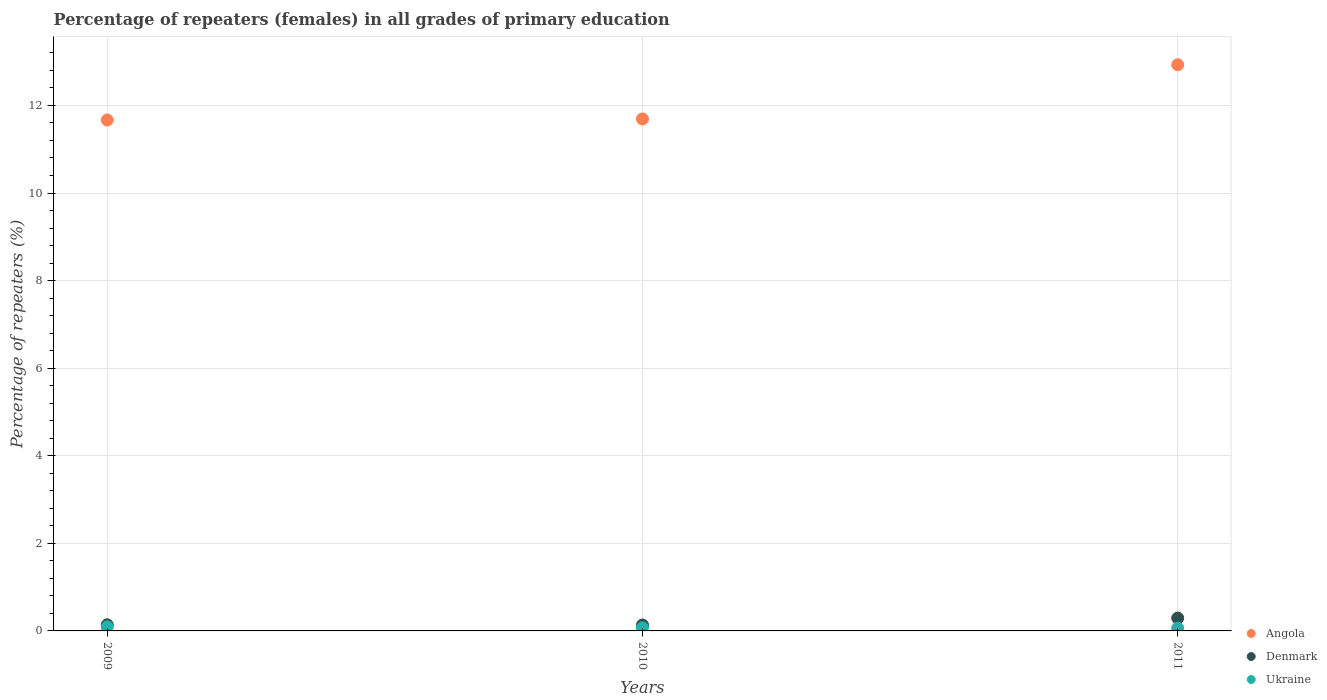Is the number of dotlines equal to the number of legend labels?
Offer a terse response. Yes. What is the percentage of repeaters (females) in Angola in 2011?
Offer a very short reply. 12.93. Across all years, what is the maximum percentage of repeaters (females) in Ukraine?
Give a very brief answer. 0.09. Across all years, what is the minimum percentage of repeaters (females) in Ukraine?
Offer a terse response. 0.06. In which year was the percentage of repeaters (females) in Angola maximum?
Offer a very short reply. 2011. In which year was the percentage of repeaters (females) in Denmark minimum?
Give a very brief answer. 2010. What is the total percentage of repeaters (females) in Ukraine in the graph?
Give a very brief answer. 0.23. What is the difference between the percentage of repeaters (females) in Angola in 2010 and that in 2011?
Offer a very short reply. -1.24. What is the difference between the percentage of repeaters (females) in Ukraine in 2009 and the percentage of repeaters (females) in Denmark in 2010?
Provide a short and direct response. -0.04. What is the average percentage of repeaters (females) in Ukraine per year?
Your response must be concise. 0.08. In the year 2010, what is the difference between the percentage of repeaters (females) in Ukraine and percentage of repeaters (females) in Angola?
Your response must be concise. -11.62. In how many years, is the percentage of repeaters (females) in Angola greater than 11.6 %?
Keep it short and to the point. 3. What is the ratio of the percentage of repeaters (females) in Denmark in 2009 to that in 2010?
Provide a succinct answer. 1.04. What is the difference between the highest and the second highest percentage of repeaters (females) in Ukraine?
Offer a very short reply. 0.02. What is the difference between the highest and the lowest percentage of repeaters (females) in Ukraine?
Give a very brief answer. 0.03. In how many years, is the percentage of repeaters (females) in Ukraine greater than the average percentage of repeaters (females) in Ukraine taken over all years?
Your answer should be compact. 1. Is it the case that in every year, the sum of the percentage of repeaters (females) in Ukraine and percentage of repeaters (females) in Angola  is greater than the percentage of repeaters (females) in Denmark?
Your answer should be compact. Yes. Is the percentage of repeaters (females) in Ukraine strictly greater than the percentage of repeaters (females) in Angola over the years?
Your response must be concise. No. Is the percentage of repeaters (females) in Ukraine strictly less than the percentage of repeaters (females) in Denmark over the years?
Offer a terse response. Yes. How many dotlines are there?
Provide a succinct answer. 3. What is the difference between two consecutive major ticks on the Y-axis?
Ensure brevity in your answer.  2. Does the graph contain any zero values?
Keep it short and to the point. No. Does the graph contain grids?
Ensure brevity in your answer.  Yes. Where does the legend appear in the graph?
Your answer should be compact. Bottom right. How many legend labels are there?
Your answer should be very brief. 3. How are the legend labels stacked?
Your answer should be compact. Vertical. What is the title of the graph?
Make the answer very short. Percentage of repeaters (females) in all grades of primary education. Does "Germany" appear as one of the legend labels in the graph?
Provide a short and direct response. No. What is the label or title of the X-axis?
Keep it short and to the point. Years. What is the label or title of the Y-axis?
Your answer should be very brief. Percentage of repeaters (%). What is the Percentage of repeaters (%) of Angola in 2009?
Keep it short and to the point. 11.67. What is the Percentage of repeaters (%) of Denmark in 2009?
Make the answer very short. 0.14. What is the Percentage of repeaters (%) in Ukraine in 2009?
Your answer should be compact. 0.09. What is the Percentage of repeaters (%) in Angola in 2010?
Your answer should be compact. 11.69. What is the Percentage of repeaters (%) of Denmark in 2010?
Give a very brief answer. 0.14. What is the Percentage of repeaters (%) in Ukraine in 2010?
Your answer should be very brief. 0.07. What is the Percentage of repeaters (%) of Angola in 2011?
Ensure brevity in your answer.  12.93. What is the Percentage of repeaters (%) in Denmark in 2011?
Offer a very short reply. 0.29. What is the Percentage of repeaters (%) in Ukraine in 2011?
Offer a terse response. 0.06. Across all years, what is the maximum Percentage of repeaters (%) in Angola?
Your answer should be very brief. 12.93. Across all years, what is the maximum Percentage of repeaters (%) of Denmark?
Ensure brevity in your answer.  0.29. Across all years, what is the maximum Percentage of repeaters (%) of Ukraine?
Offer a very short reply. 0.09. Across all years, what is the minimum Percentage of repeaters (%) of Angola?
Your response must be concise. 11.67. Across all years, what is the minimum Percentage of repeaters (%) of Denmark?
Ensure brevity in your answer.  0.14. Across all years, what is the minimum Percentage of repeaters (%) of Ukraine?
Provide a short and direct response. 0.06. What is the total Percentage of repeaters (%) in Angola in the graph?
Ensure brevity in your answer.  36.29. What is the total Percentage of repeaters (%) in Denmark in the graph?
Your answer should be compact. 0.57. What is the total Percentage of repeaters (%) in Ukraine in the graph?
Provide a succinct answer. 0.23. What is the difference between the Percentage of repeaters (%) in Angola in 2009 and that in 2010?
Your response must be concise. -0.02. What is the difference between the Percentage of repeaters (%) in Denmark in 2009 and that in 2010?
Give a very brief answer. 0. What is the difference between the Percentage of repeaters (%) of Ukraine in 2009 and that in 2010?
Give a very brief answer. 0.02. What is the difference between the Percentage of repeaters (%) in Angola in 2009 and that in 2011?
Your answer should be very brief. -1.26. What is the difference between the Percentage of repeaters (%) in Denmark in 2009 and that in 2011?
Your answer should be compact. -0.15. What is the difference between the Percentage of repeaters (%) in Ukraine in 2009 and that in 2011?
Your response must be concise. 0.03. What is the difference between the Percentage of repeaters (%) in Angola in 2010 and that in 2011?
Give a very brief answer. -1.24. What is the difference between the Percentage of repeaters (%) of Denmark in 2010 and that in 2011?
Offer a terse response. -0.16. What is the difference between the Percentage of repeaters (%) in Ukraine in 2010 and that in 2011?
Provide a short and direct response. 0.01. What is the difference between the Percentage of repeaters (%) of Angola in 2009 and the Percentage of repeaters (%) of Denmark in 2010?
Your answer should be compact. 11.53. What is the difference between the Percentage of repeaters (%) in Angola in 2009 and the Percentage of repeaters (%) in Ukraine in 2010?
Your answer should be compact. 11.6. What is the difference between the Percentage of repeaters (%) of Denmark in 2009 and the Percentage of repeaters (%) of Ukraine in 2010?
Offer a very short reply. 0.07. What is the difference between the Percentage of repeaters (%) in Angola in 2009 and the Percentage of repeaters (%) in Denmark in 2011?
Provide a succinct answer. 11.37. What is the difference between the Percentage of repeaters (%) in Angola in 2009 and the Percentage of repeaters (%) in Ukraine in 2011?
Offer a very short reply. 11.6. What is the difference between the Percentage of repeaters (%) of Denmark in 2009 and the Percentage of repeaters (%) of Ukraine in 2011?
Make the answer very short. 0.08. What is the difference between the Percentage of repeaters (%) in Angola in 2010 and the Percentage of repeaters (%) in Denmark in 2011?
Keep it short and to the point. 11.4. What is the difference between the Percentage of repeaters (%) in Angola in 2010 and the Percentage of repeaters (%) in Ukraine in 2011?
Give a very brief answer. 11.63. What is the difference between the Percentage of repeaters (%) in Denmark in 2010 and the Percentage of repeaters (%) in Ukraine in 2011?
Ensure brevity in your answer.  0.07. What is the average Percentage of repeaters (%) in Angola per year?
Keep it short and to the point. 12.1. What is the average Percentage of repeaters (%) in Denmark per year?
Your answer should be very brief. 0.19. What is the average Percentage of repeaters (%) of Ukraine per year?
Ensure brevity in your answer.  0.08. In the year 2009, what is the difference between the Percentage of repeaters (%) in Angola and Percentage of repeaters (%) in Denmark?
Offer a terse response. 11.53. In the year 2009, what is the difference between the Percentage of repeaters (%) of Angola and Percentage of repeaters (%) of Ukraine?
Keep it short and to the point. 11.57. In the year 2009, what is the difference between the Percentage of repeaters (%) of Denmark and Percentage of repeaters (%) of Ukraine?
Provide a short and direct response. 0.05. In the year 2010, what is the difference between the Percentage of repeaters (%) of Angola and Percentage of repeaters (%) of Denmark?
Offer a terse response. 11.56. In the year 2010, what is the difference between the Percentage of repeaters (%) of Angola and Percentage of repeaters (%) of Ukraine?
Give a very brief answer. 11.62. In the year 2010, what is the difference between the Percentage of repeaters (%) in Denmark and Percentage of repeaters (%) in Ukraine?
Offer a very short reply. 0.06. In the year 2011, what is the difference between the Percentage of repeaters (%) in Angola and Percentage of repeaters (%) in Denmark?
Offer a terse response. 12.63. In the year 2011, what is the difference between the Percentage of repeaters (%) in Angola and Percentage of repeaters (%) in Ukraine?
Offer a terse response. 12.86. In the year 2011, what is the difference between the Percentage of repeaters (%) in Denmark and Percentage of repeaters (%) in Ukraine?
Give a very brief answer. 0.23. What is the ratio of the Percentage of repeaters (%) of Angola in 2009 to that in 2010?
Your answer should be compact. 1. What is the ratio of the Percentage of repeaters (%) of Denmark in 2009 to that in 2010?
Provide a short and direct response. 1.04. What is the ratio of the Percentage of repeaters (%) in Ukraine in 2009 to that in 2010?
Ensure brevity in your answer.  1.3. What is the ratio of the Percentage of repeaters (%) in Angola in 2009 to that in 2011?
Give a very brief answer. 0.9. What is the ratio of the Percentage of repeaters (%) in Denmark in 2009 to that in 2011?
Keep it short and to the point. 0.48. What is the ratio of the Percentage of repeaters (%) in Ukraine in 2009 to that in 2011?
Offer a very short reply. 1.45. What is the ratio of the Percentage of repeaters (%) of Angola in 2010 to that in 2011?
Your response must be concise. 0.9. What is the ratio of the Percentage of repeaters (%) of Denmark in 2010 to that in 2011?
Offer a very short reply. 0.46. What is the ratio of the Percentage of repeaters (%) of Ukraine in 2010 to that in 2011?
Provide a succinct answer. 1.11. What is the difference between the highest and the second highest Percentage of repeaters (%) of Angola?
Make the answer very short. 1.24. What is the difference between the highest and the second highest Percentage of repeaters (%) in Denmark?
Offer a very short reply. 0.15. What is the difference between the highest and the second highest Percentage of repeaters (%) of Ukraine?
Your answer should be compact. 0.02. What is the difference between the highest and the lowest Percentage of repeaters (%) in Angola?
Give a very brief answer. 1.26. What is the difference between the highest and the lowest Percentage of repeaters (%) in Denmark?
Your response must be concise. 0.16. What is the difference between the highest and the lowest Percentage of repeaters (%) of Ukraine?
Your response must be concise. 0.03. 